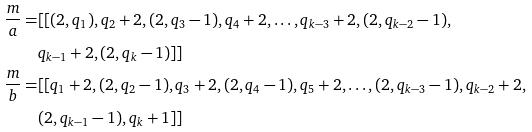<formula> <loc_0><loc_0><loc_500><loc_500>\frac { m } { a } = & [ [ ( 2 , q _ { 1 } ) , q _ { 2 } + 2 , ( 2 , q _ { 3 } - 1 ) , q _ { 4 } + 2 , \dots , q _ { k - 3 } + 2 , ( 2 , q _ { k - 2 } - 1 ) , \\ & q _ { k - 1 } + 2 , ( 2 , q _ { k } - 1 ) ] ] \\ \frac { m } { b } = & [ [ q _ { 1 } + 2 , ( 2 , q _ { 2 } - 1 ) , q _ { 3 } + 2 , ( 2 , q _ { 4 } - 1 ) , q _ { 5 } + 2 , \dots , ( 2 , q _ { k - 3 } - 1 ) , q _ { k - 2 } + 2 , \\ & ( 2 , q _ { k - 1 } - 1 ) , q _ { k } + 1 ] ]</formula> 